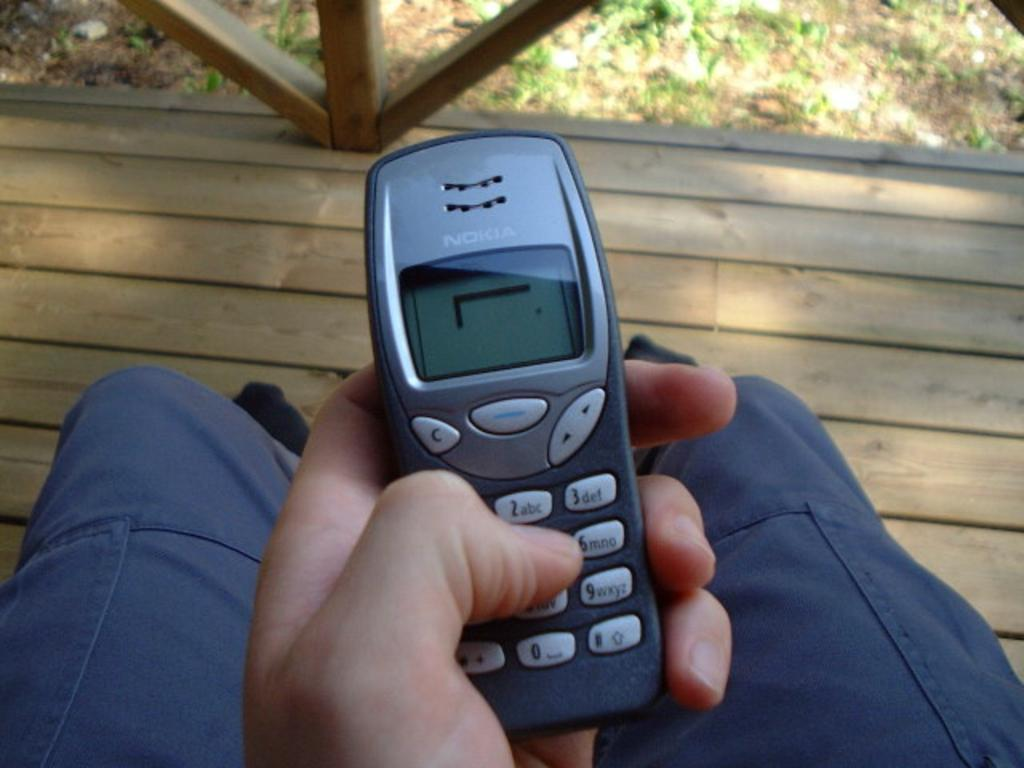What is the main subject of the image? There is a person in the image. What is the person holding in the image? The person is holding a mobile in the image. What type of natural environment is visible in the background of the image? There is grass in the background of the image. What type of man-made structure is visible in the background of the image? There is a wooden pathway in the background of the image. What type of gold object can be seen on the side of the person in the image? There is no gold object visible on the person or the side of the person in the image. 